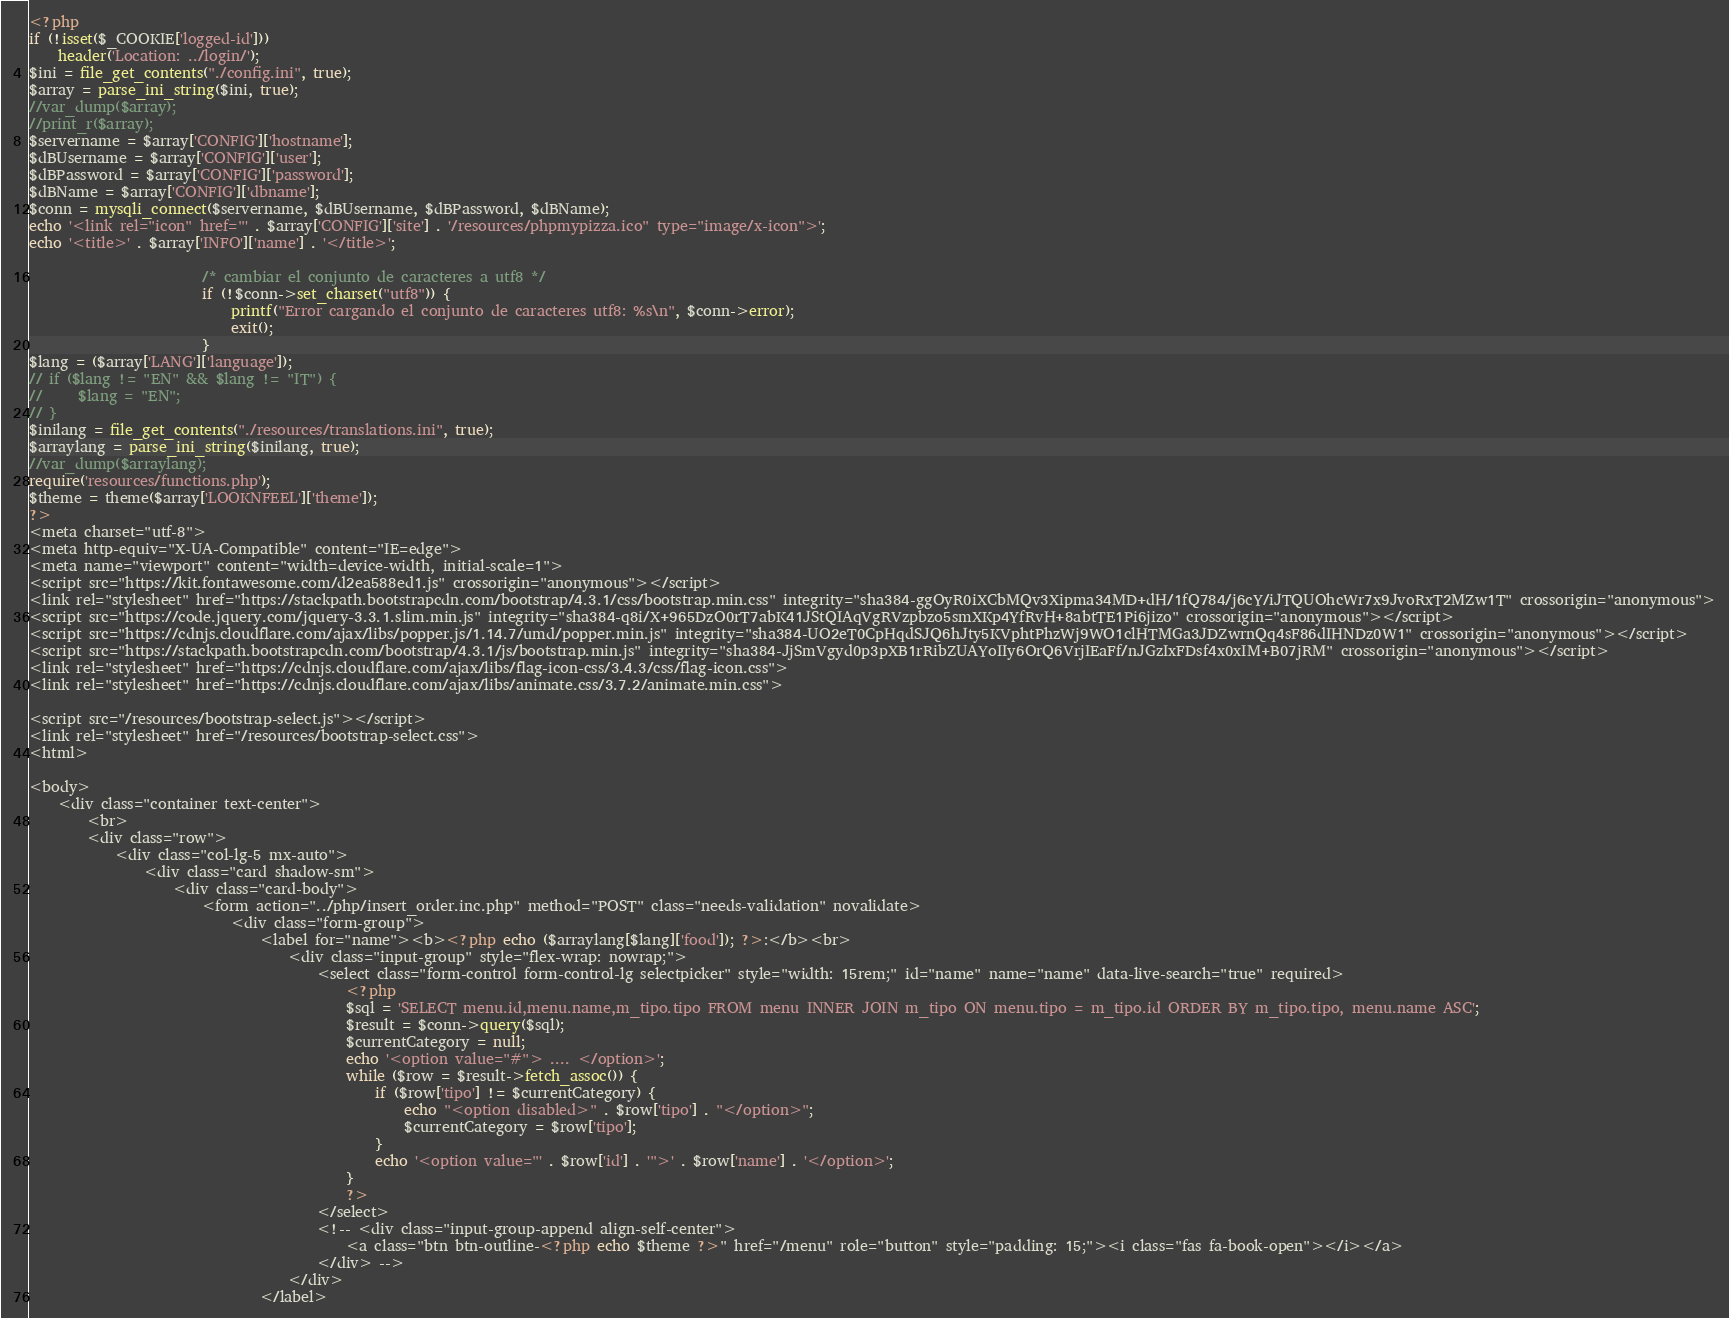<code> <loc_0><loc_0><loc_500><loc_500><_PHP_><?php
if (!isset($_COOKIE['logged-id']))
    header('Location: ../login/');
$ini = file_get_contents("./config.ini", true);
$array = parse_ini_string($ini, true);
//var_dump($array);
//print_r($array);
$servername = $array['CONFIG']['hostname'];
$dBUsername = $array['CONFIG']['user'];
$dBPassword = $array['CONFIG']['password'];
$dBName = $array['CONFIG']['dbname'];
$conn = mysqli_connect($servername, $dBUsername, $dBPassword, $dBName);
echo '<link rel="icon" href="' . $array['CONFIG']['site'] . '/resources/phpmypizza.ico" type="image/x-icon">';
echo '<title>' . $array['INFO']['name'] . '</title>';

                        /* cambiar el conjunto de caracteres a utf8 */
                        if (!$conn->set_charset("utf8")) {
                            printf("Error cargando el conjunto de caracteres utf8: %s\n", $conn->error);
                            exit();
                        }                         
$lang = ($array['LANG']['language']);
// if ($lang != "EN" && $lang != "IT") {
//     $lang = "EN";
// }
$inilang = file_get_contents("./resources/translations.ini", true);
$arraylang = parse_ini_string($inilang, true);
//var_dump($arraylang);
require('resources/functions.php');
$theme = theme($array['LOOKNFEEL']['theme']);
?>
<meta charset="utf-8">
<meta http-equiv="X-UA-Compatible" content="IE=edge">
<meta name="viewport" content="width=device-width, initial-scale=1">
<script src="https://kit.fontawesome.com/d2ea588ed1.js" crossorigin="anonymous"></script>
<link rel="stylesheet" href="https://stackpath.bootstrapcdn.com/bootstrap/4.3.1/css/bootstrap.min.css" integrity="sha384-ggOyR0iXCbMQv3Xipma34MD+dH/1fQ784/j6cY/iJTQUOhcWr7x9JvoRxT2MZw1T" crossorigin="anonymous">
<script src="https://code.jquery.com/jquery-3.3.1.slim.min.js" integrity="sha384-q8i/X+965DzO0rT7abK41JStQIAqVgRVzpbzo5smXKp4YfRvH+8abtTE1Pi6jizo" crossorigin="anonymous"></script>
<script src="https://cdnjs.cloudflare.com/ajax/libs/popper.js/1.14.7/umd/popper.min.js" integrity="sha384-UO2eT0CpHqdSJQ6hJty5KVphtPhzWj9WO1clHTMGa3JDZwrnQq4sF86dIHNDz0W1" crossorigin="anonymous"></script>
<script src="https://stackpath.bootstrapcdn.com/bootstrap/4.3.1/js/bootstrap.min.js" integrity="sha384-JjSmVgyd0p3pXB1rRibZUAYoIIy6OrQ6VrjIEaFf/nJGzIxFDsf4x0xIM+B07jRM" crossorigin="anonymous"></script>
<link rel="stylesheet" href="https://cdnjs.cloudflare.com/ajax/libs/flag-icon-css/3.4.3/css/flag-icon.css">
<link rel="stylesheet" href="https://cdnjs.cloudflare.com/ajax/libs/animate.css/3.7.2/animate.min.css">

<script src="/resources/bootstrap-select.js"></script>
<link rel="stylesheet" href="/resources/bootstrap-select.css">
<html>

<body>
    <div class="container text-center">
        <br>
        <div class="row">
            <div class="col-lg-5 mx-auto">
                <div class="card shadow-sm">
                    <div class="card-body">
                        <form action="../php/insert_order.inc.php" method="POST" class="needs-validation" novalidate>
                            <div class="form-group">
                                <label for="name"><b><?php echo ($arraylang[$lang]['food']); ?>:</b><br>
                                    <div class="input-group" style="flex-wrap: nowrap;">
                                        <select class="form-control form-control-lg selectpicker" style="width: 15rem;" id="name" name="name" data-live-search="true" required>
                                            <?php
                                            $sql = 'SELECT menu.id,menu.name,m_tipo.tipo FROM menu INNER JOIN m_tipo ON menu.tipo = m_tipo.id ORDER BY m_tipo.tipo, menu.name ASC';
                                            $result = $conn->query($sql);
                                            $currentCategory = null;
                                            echo '<option value="#"> .... </option>';
                                            while ($row = $result->fetch_assoc()) {
                                                if ($row['tipo'] != $currentCategory) {
                                                    echo "<option disabled>" . $row['tipo'] . "</option>";
                                                    $currentCategory = $row['tipo'];
                                                }
                                                echo '<option value="' . $row['id'] . '">' . $row['name'] . '</option>';
                                            }
                                            ?>
                                        </select>
                                        <!-- <div class="input-group-append align-self-center">
                                            <a class="btn btn-outline-<?php echo $theme ?>" href="/menu" role="button" style="padding: 15;"><i class="fas fa-book-open"></i></a>
                                        </div> -->
                                    </div>
                                </label></code> 